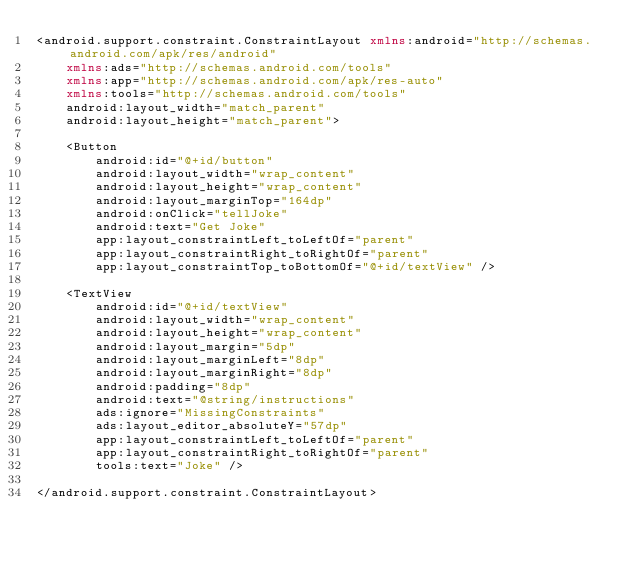Convert code to text. <code><loc_0><loc_0><loc_500><loc_500><_XML_><android.support.constraint.ConstraintLayout xmlns:android="http://schemas.android.com/apk/res/android"
    xmlns:ads="http://schemas.android.com/tools"
    xmlns:app="http://schemas.android.com/apk/res-auto"
    xmlns:tools="http://schemas.android.com/tools"
    android:layout_width="match_parent"
    android:layout_height="match_parent">

    <Button
        android:id="@+id/button"
        android:layout_width="wrap_content"
        android:layout_height="wrap_content"
        android:layout_marginTop="164dp"
        android:onClick="tellJoke"
        android:text="Get Joke"
        app:layout_constraintLeft_toLeftOf="parent"
        app:layout_constraintRight_toRightOf="parent"
        app:layout_constraintTop_toBottomOf="@+id/textView" />

    <TextView
        android:id="@+id/textView"
        android:layout_width="wrap_content"
        android:layout_height="wrap_content"
        android:layout_margin="5dp"
        android:layout_marginLeft="8dp"
        android:layout_marginRight="8dp"
        android:padding="8dp"
        android:text="@string/instructions"
        ads:ignore="MissingConstraints"
        ads:layout_editor_absoluteY="57dp"
        app:layout_constraintLeft_toLeftOf="parent"
        app:layout_constraintRight_toRightOf="parent"
        tools:text="Joke" />

</android.support.constraint.ConstraintLayout></code> 